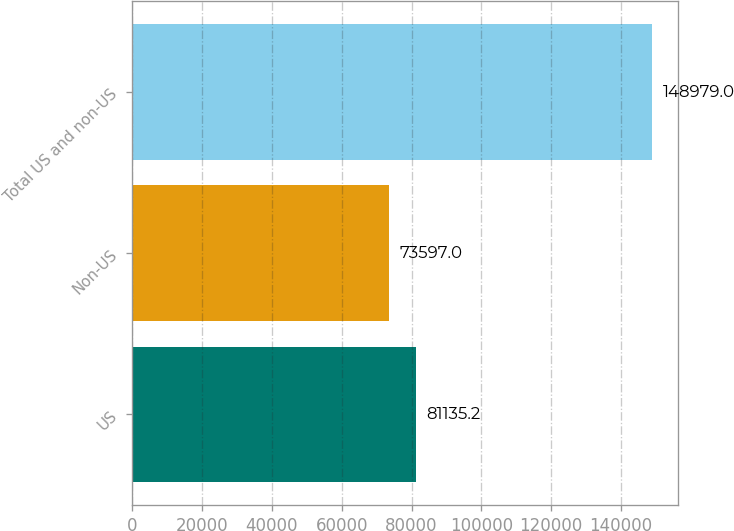Convert chart. <chart><loc_0><loc_0><loc_500><loc_500><bar_chart><fcel>US<fcel>Non-US<fcel>Total US and non-US<nl><fcel>81135.2<fcel>73597<fcel>148979<nl></chart> 